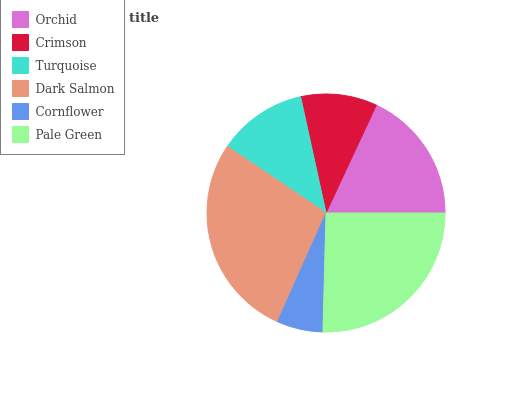Is Cornflower the minimum?
Answer yes or no. Yes. Is Dark Salmon the maximum?
Answer yes or no. Yes. Is Crimson the minimum?
Answer yes or no. No. Is Crimson the maximum?
Answer yes or no. No. Is Orchid greater than Crimson?
Answer yes or no. Yes. Is Crimson less than Orchid?
Answer yes or no. Yes. Is Crimson greater than Orchid?
Answer yes or no. No. Is Orchid less than Crimson?
Answer yes or no. No. Is Orchid the high median?
Answer yes or no. Yes. Is Turquoise the low median?
Answer yes or no. Yes. Is Turquoise the high median?
Answer yes or no. No. Is Dark Salmon the low median?
Answer yes or no. No. 